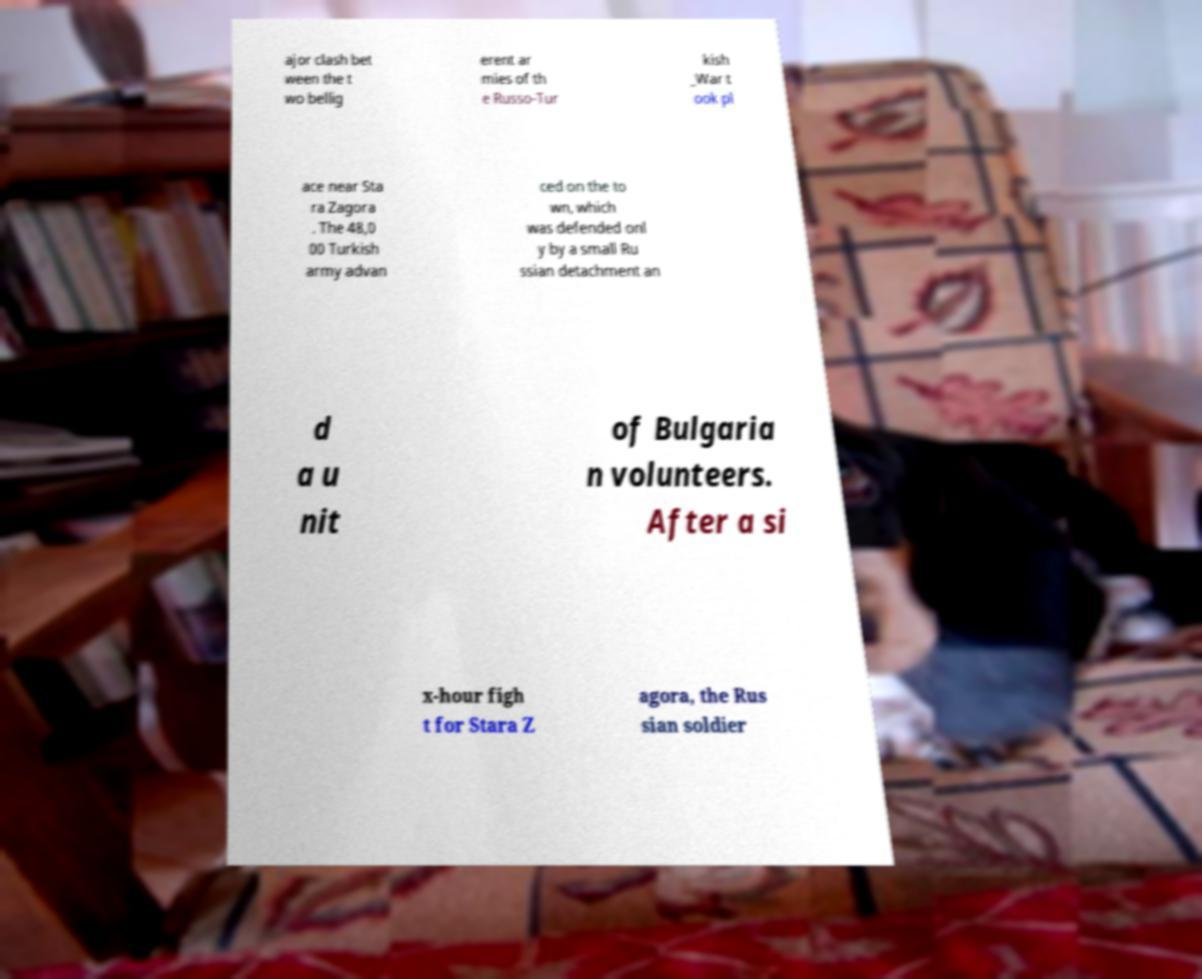Could you extract and type out the text from this image? ajor clash bet ween the t wo bellig erent ar mies of th e Russo-Tur kish _War t ook pl ace near Sta ra Zagora . The 48,0 00 Turkish army advan ced on the to wn, which was defended onl y by a small Ru ssian detachment an d a u nit of Bulgaria n volunteers. After a si x-hour figh t for Stara Z agora, the Rus sian soldier 